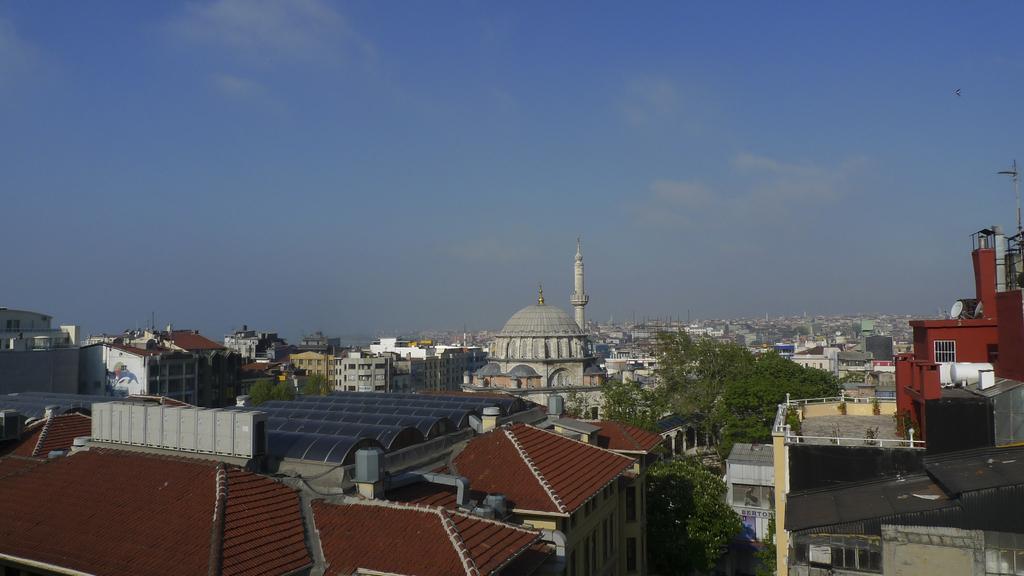Could you give a brief overview of what you see in this image? In this picture I can see many buildings, poles, shed and other objects. In the bottom left I can see the solar panels on the roof of the building. In the center I can see the mosque. At the top I can see the sky and clouds. 